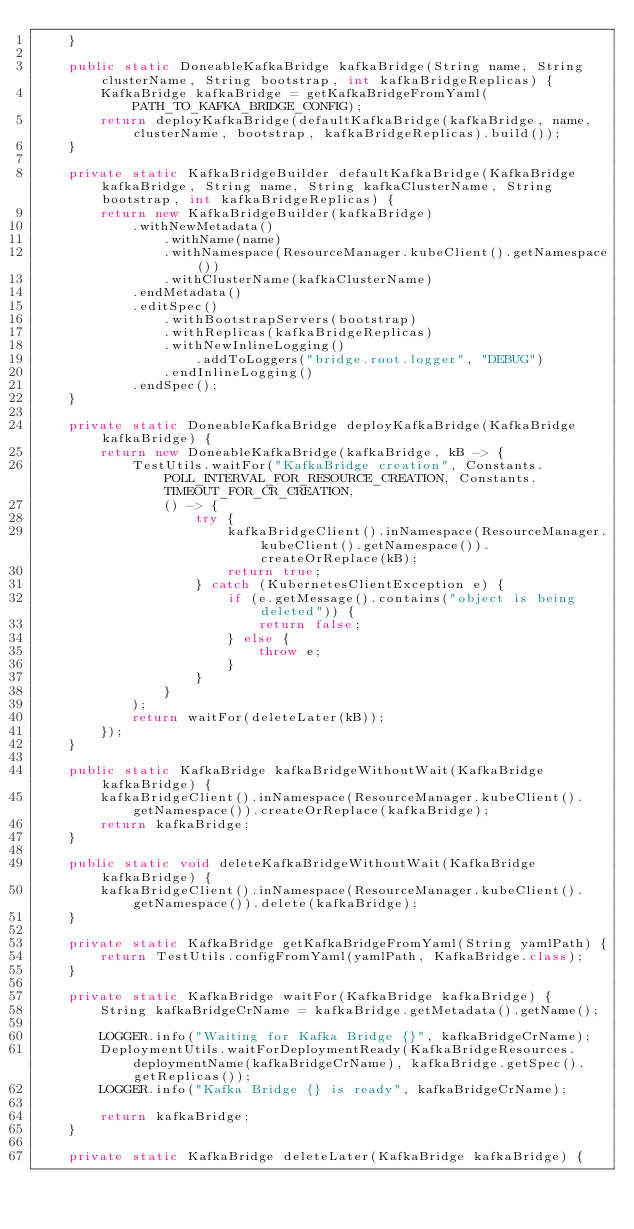<code> <loc_0><loc_0><loc_500><loc_500><_Java_>    }

    public static DoneableKafkaBridge kafkaBridge(String name, String clusterName, String bootstrap, int kafkaBridgeReplicas) {
        KafkaBridge kafkaBridge = getKafkaBridgeFromYaml(PATH_TO_KAFKA_BRIDGE_CONFIG);
        return deployKafkaBridge(defaultKafkaBridge(kafkaBridge, name, clusterName, bootstrap, kafkaBridgeReplicas).build());
    }

    private static KafkaBridgeBuilder defaultKafkaBridge(KafkaBridge kafkaBridge, String name, String kafkaClusterName, String bootstrap, int kafkaBridgeReplicas) {
        return new KafkaBridgeBuilder(kafkaBridge)
            .withNewMetadata()
                .withName(name)
                .withNamespace(ResourceManager.kubeClient().getNamespace())
                .withClusterName(kafkaClusterName)
            .endMetadata()
            .editSpec()
                .withBootstrapServers(bootstrap)
                .withReplicas(kafkaBridgeReplicas)
                .withNewInlineLogging()
                    .addToLoggers("bridge.root.logger", "DEBUG")
                .endInlineLogging()
            .endSpec();
    }

    private static DoneableKafkaBridge deployKafkaBridge(KafkaBridge kafkaBridge) {
        return new DoneableKafkaBridge(kafkaBridge, kB -> {
            TestUtils.waitFor("KafkaBridge creation", Constants.POLL_INTERVAL_FOR_RESOURCE_CREATION, Constants.TIMEOUT_FOR_CR_CREATION,
                () -> {
                    try {
                        kafkaBridgeClient().inNamespace(ResourceManager.kubeClient().getNamespace()).createOrReplace(kB);
                        return true;
                    } catch (KubernetesClientException e) {
                        if (e.getMessage().contains("object is being deleted")) {
                            return false;
                        } else {
                            throw e;
                        }
                    }
                }
            );
            return waitFor(deleteLater(kB));
        });
    }

    public static KafkaBridge kafkaBridgeWithoutWait(KafkaBridge kafkaBridge) {
        kafkaBridgeClient().inNamespace(ResourceManager.kubeClient().getNamespace()).createOrReplace(kafkaBridge);
        return kafkaBridge;
    }

    public static void deleteKafkaBridgeWithoutWait(KafkaBridge kafkaBridge) {
        kafkaBridgeClient().inNamespace(ResourceManager.kubeClient().getNamespace()).delete(kafkaBridge);
    }

    private static KafkaBridge getKafkaBridgeFromYaml(String yamlPath) {
        return TestUtils.configFromYaml(yamlPath, KafkaBridge.class);
    }

    private static KafkaBridge waitFor(KafkaBridge kafkaBridge) {
        String kafkaBridgeCrName = kafkaBridge.getMetadata().getName();

        LOGGER.info("Waiting for Kafka Bridge {}", kafkaBridgeCrName);
        DeploymentUtils.waitForDeploymentReady(KafkaBridgeResources.deploymentName(kafkaBridgeCrName), kafkaBridge.getSpec().getReplicas());
        LOGGER.info("Kafka Bridge {} is ready", kafkaBridgeCrName);

        return kafkaBridge;
    }

    private static KafkaBridge deleteLater(KafkaBridge kafkaBridge) {</code> 